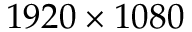Convert formula to latex. <formula><loc_0><loc_0><loc_500><loc_500>1 9 2 0 \times 1 0 8 0</formula> 